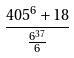Convert formula to latex. <formula><loc_0><loc_0><loc_500><loc_500>\frac { 4 0 5 ^ { 6 } + 1 8 } { \frac { 6 ^ { 3 7 } } { 6 } }</formula> 